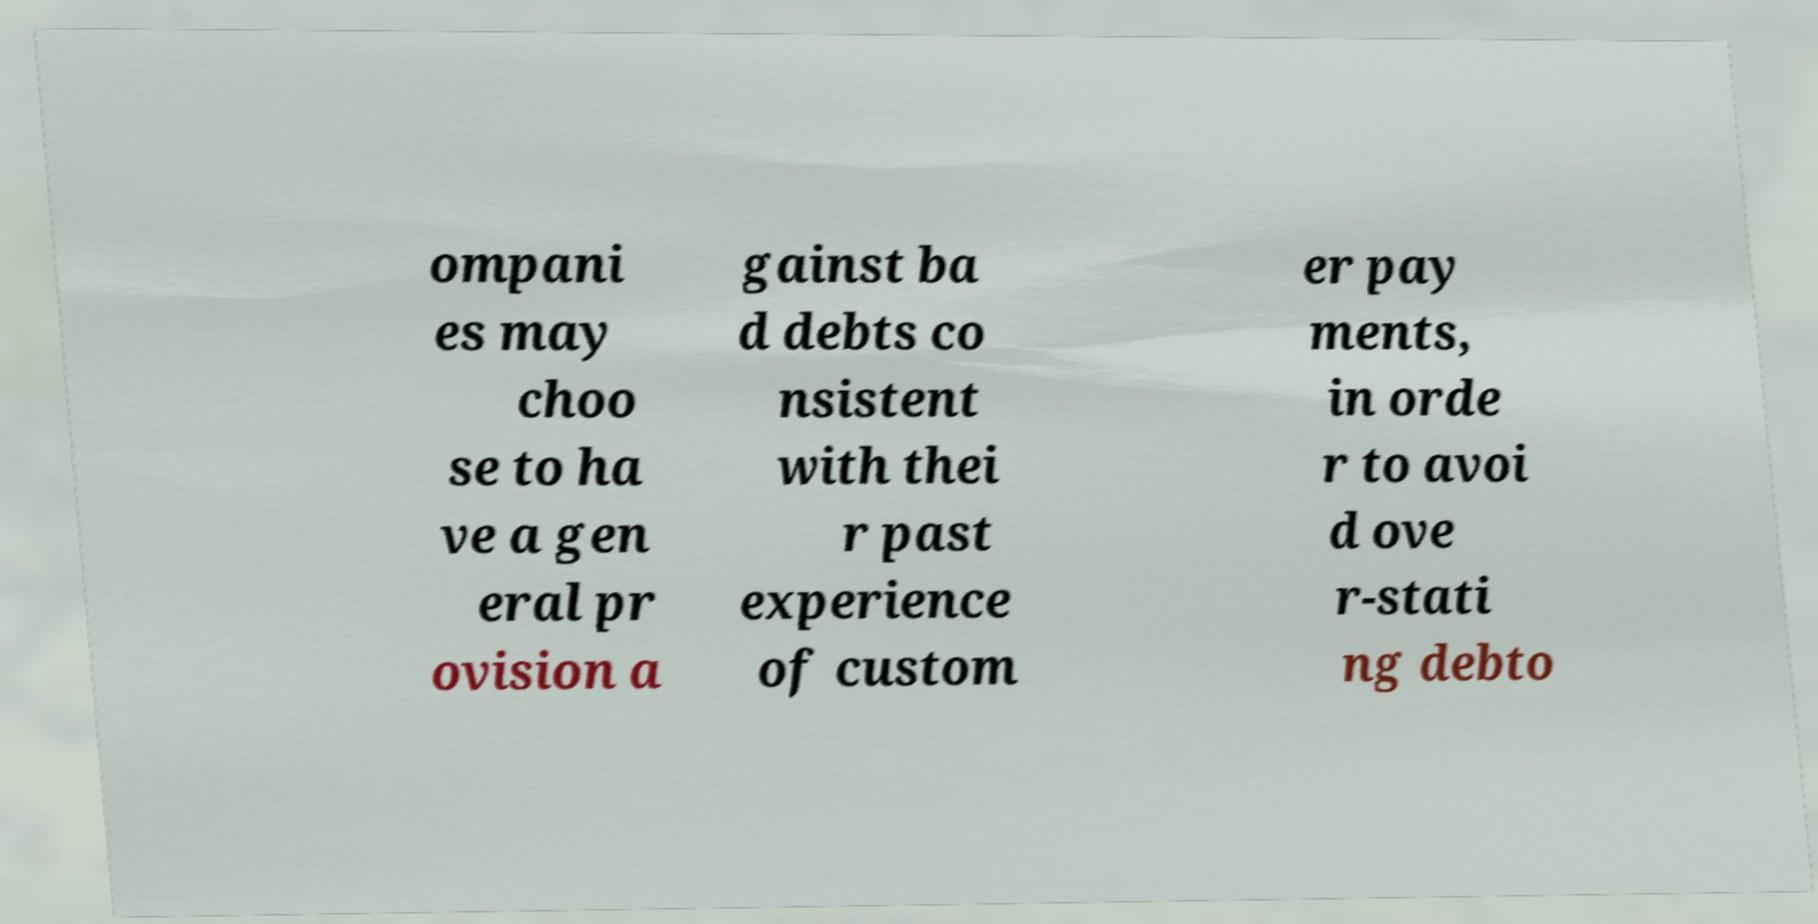Please read and relay the text visible in this image. What does it say? ompani es may choo se to ha ve a gen eral pr ovision a gainst ba d debts co nsistent with thei r past experience of custom er pay ments, in orde r to avoi d ove r-stati ng debto 